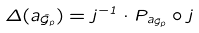<formula> <loc_0><loc_0><loc_500><loc_500>\Delta ( \L a _ { \hat { \mathcal { G } } _ { p } } ) = j ^ { - 1 } \cdot P _ { \L a _ { \hat { \mathcal { G } } _ { p } } } \circ j</formula> 